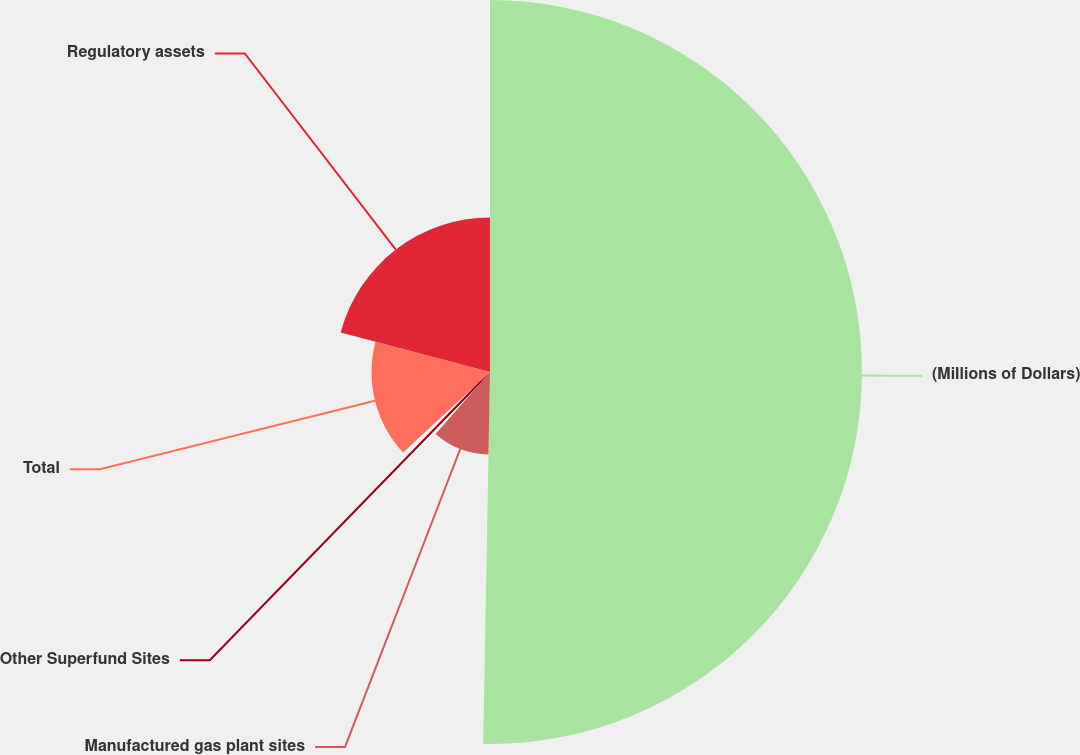<chart> <loc_0><loc_0><loc_500><loc_500><pie_chart><fcel>(Millions of Dollars)<fcel>Manufactured gas plant sites<fcel>Other Superfund Sites<fcel>Total<fcel>Regulatory assets<nl><fcel>50.29%<fcel>11.16%<fcel>1.65%<fcel>16.02%<fcel>20.88%<nl></chart> 